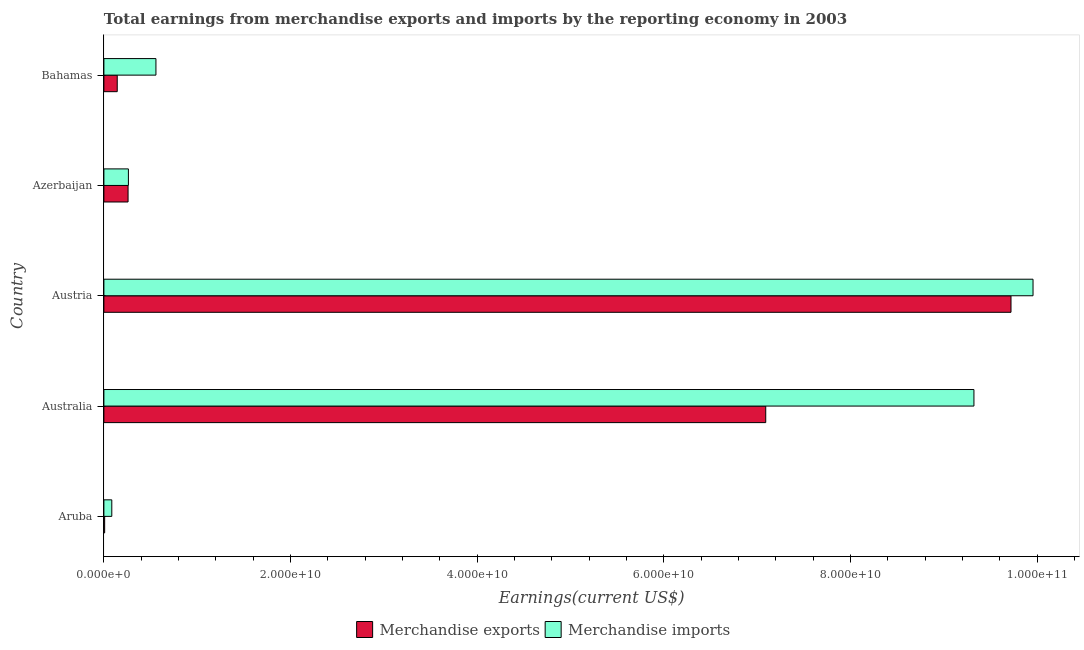How many different coloured bars are there?
Ensure brevity in your answer.  2. Are the number of bars per tick equal to the number of legend labels?
Your answer should be very brief. Yes. Are the number of bars on each tick of the Y-axis equal?
Provide a succinct answer. Yes. How many bars are there on the 4th tick from the bottom?
Offer a terse response. 2. What is the label of the 1st group of bars from the top?
Provide a succinct answer. Bahamas. In how many cases, is the number of bars for a given country not equal to the number of legend labels?
Ensure brevity in your answer.  0. What is the earnings from merchandise exports in Bahamas?
Offer a very short reply. 1.43e+09. Across all countries, what is the maximum earnings from merchandise imports?
Give a very brief answer. 9.95e+1. Across all countries, what is the minimum earnings from merchandise imports?
Provide a succinct answer. 8.47e+08. In which country was the earnings from merchandise imports maximum?
Make the answer very short. Austria. In which country was the earnings from merchandise imports minimum?
Your answer should be very brief. Aruba. What is the total earnings from merchandise exports in the graph?
Your answer should be very brief. 1.72e+11. What is the difference between the earnings from merchandise imports in Aruba and that in Australia?
Offer a very short reply. -9.24e+1. What is the difference between the earnings from merchandise imports in Azerbaijan and the earnings from merchandise exports in Bahamas?
Give a very brief answer. 1.20e+09. What is the average earnings from merchandise imports per country?
Give a very brief answer. 4.04e+1. What is the difference between the earnings from merchandise exports and earnings from merchandise imports in Austria?
Make the answer very short. -2.36e+09. What is the ratio of the earnings from merchandise exports in Aruba to that in Azerbaijan?
Your response must be concise. 0.03. What is the difference between the highest and the second highest earnings from merchandise exports?
Offer a very short reply. 2.63e+1. What is the difference between the highest and the lowest earnings from merchandise exports?
Provide a succinct answer. 9.71e+1. How many bars are there?
Offer a terse response. 10. How many countries are there in the graph?
Provide a succinct answer. 5. Are the values on the major ticks of X-axis written in scientific E-notation?
Provide a short and direct response. Yes. Where does the legend appear in the graph?
Provide a short and direct response. Bottom center. How many legend labels are there?
Provide a short and direct response. 2. How are the legend labels stacked?
Offer a terse response. Horizontal. What is the title of the graph?
Provide a succinct answer. Total earnings from merchandise exports and imports by the reporting economy in 2003. Does "Food" appear as one of the legend labels in the graph?
Your answer should be very brief. No. What is the label or title of the X-axis?
Offer a terse response. Earnings(current US$). What is the label or title of the Y-axis?
Provide a short and direct response. Country. What is the Earnings(current US$) of Merchandise exports in Aruba?
Ensure brevity in your answer.  8.22e+07. What is the Earnings(current US$) in Merchandise imports in Aruba?
Offer a very short reply. 8.47e+08. What is the Earnings(current US$) of Merchandise exports in Australia?
Give a very brief answer. 7.09e+1. What is the Earnings(current US$) of Merchandise imports in Australia?
Your response must be concise. 9.32e+1. What is the Earnings(current US$) of Merchandise exports in Austria?
Provide a succinct answer. 9.72e+1. What is the Earnings(current US$) of Merchandise imports in Austria?
Provide a succinct answer. 9.95e+1. What is the Earnings(current US$) in Merchandise exports in Azerbaijan?
Offer a terse response. 2.59e+09. What is the Earnings(current US$) of Merchandise imports in Azerbaijan?
Provide a short and direct response. 2.63e+09. What is the Earnings(current US$) of Merchandise exports in Bahamas?
Ensure brevity in your answer.  1.43e+09. What is the Earnings(current US$) in Merchandise imports in Bahamas?
Make the answer very short. 5.58e+09. Across all countries, what is the maximum Earnings(current US$) in Merchandise exports?
Your answer should be compact. 9.72e+1. Across all countries, what is the maximum Earnings(current US$) in Merchandise imports?
Provide a succinct answer. 9.95e+1. Across all countries, what is the minimum Earnings(current US$) in Merchandise exports?
Keep it short and to the point. 8.22e+07. Across all countries, what is the minimum Earnings(current US$) in Merchandise imports?
Keep it short and to the point. 8.47e+08. What is the total Earnings(current US$) in Merchandise exports in the graph?
Your answer should be very brief. 1.72e+11. What is the total Earnings(current US$) of Merchandise imports in the graph?
Your response must be concise. 2.02e+11. What is the difference between the Earnings(current US$) of Merchandise exports in Aruba and that in Australia?
Your answer should be very brief. -7.08e+1. What is the difference between the Earnings(current US$) of Merchandise imports in Aruba and that in Australia?
Offer a very short reply. -9.24e+1. What is the difference between the Earnings(current US$) of Merchandise exports in Aruba and that in Austria?
Offer a terse response. -9.71e+1. What is the difference between the Earnings(current US$) in Merchandise imports in Aruba and that in Austria?
Your response must be concise. -9.87e+1. What is the difference between the Earnings(current US$) of Merchandise exports in Aruba and that in Azerbaijan?
Ensure brevity in your answer.  -2.51e+09. What is the difference between the Earnings(current US$) of Merchandise imports in Aruba and that in Azerbaijan?
Provide a succinct answer. -1.78e+09. What is the difference between the Earnings(current US$) of Merchandise exports in Aruba and that in Bahamas?
Your response must be concise. -1.35e+09. What is the difference between the Earnings(current US$) in Merchandise imports in Aruba and that in Bahamas?
Provide a succinct answer. -4.73e+09. What is the difference between the Earnings(current US$) in Merchandise exports in Australia and that in Austria?
Offer a terse response. -2.63e+1. What is the difference between the Earnings(current US$) in Merchandise imports in Australia and that in Austria?
Ensure brevity in your answer.  -6.33e+09. What is the difference between the Earnings(current US$) of Merchandise exports in Australia and that in Azerbaijan?
Keep it short and to the point. 6.83e+1. What is the difference between the Earnings(current US$) in Merchandise imports in Australia and that in Azerbaijan?
Your answer should be compact. 9.06e+1. What is the difference between the Earnings(current US$) in Merchandise exports in Australia and that in Bahamas?
Your answer should be compact. 6.95e+1. What is the difference between the Earnings(current US$) of Merchandise imports in Australia and that in Bahamas?
Keep it short and to the point. 8.76e+1. What is the difference between the Earnings(current US$) in Merchandise exports in Austria and that in Azerbaijan?
Your response must be concise. 9.46e+1. What is the difference between the Earnings(current US$) of Merchandise imports in Austria and that in Azerbaijan?
Make the answer very short. 9.69e+1. What is the difference between the Earnings(current US$) of Merchandise exports in Austria and that in Bahamas?
Your answer should be very brief. 9.58e+1. What is the difference between the Earnings(current US$) in Merchandise imports in Austria and that in Bahamas?
Offer a very short reply. 9.40e+1. What is the difference between the Earnings(current US$) in Merchandise exports in Azerbaijan and that in Bahamas?
Make the answer very short. 1.16e+09. What is the difference between the Earnings(current US$) of Merchandise imports in Azerbaijan and that in Bahamas?
Your response must be concise. -2.95e+09. What is the difference between the Earnings(current US$) of Merchandise exports in Aruba and the Earnings(current US$) of Merchandise imports in Australia?
Your answer should be compact. -9.31e+1. What is the difference between the Earnings(current US$) in Merchandise exports in Aruba and the Earnings(current US$) in Merchandise imports in Austria?
Provide a succinct answer. -9.95e+1. What is the difference between the Earnings(current US$) in Merchandise exports in Aruba and the Earnings(current US$) in Merchandise imports in Azerbaijan?
Provide a succinct answer. -2.54e+09. What is the difference between the Earnings(current US$) in Merchandise exports in Aruba and the Earnings(current US$) in Merchandise imports in Bahamas?
Ensure brevity in your answer.  -5.49e+09. What is the difference between the Earnings(current US$) of Merchandise exports in Australia and the Earnings(current US$) of Merchandise imports in Austria?
Offer a terse response. -2.86e+1. What is the difference between the Earnings(current US$) in Merchandise exports in Australia and the Earnings(current US$) in Merchandise imports in Azerbaijan?
Offer a terse response. 6.83e+1. What is the difference between the Earnings(current US$) of Merchandise exports in Australia and the Earnings(current US$) of Merchandise imports in Bahamas?
Your answer should be compact. 6.53e+1. What is the difference between the Earnings(current US$) of Merchandise exports in Austria and the Earnings(current US$) of Merchandise imports in Azerbaijan?
Provide a succinct answer. 9.46e+1. What is the difference between the Earnings(current US$) of Merchandise exports in Austria and the Earnings(current US$) of Merchandise imports in Bahamas?
Provide a succinct answer. 9.16e+1. What is the difference between the Earnings(current US$) of Merchandise exports in Azerbaijan and the Earnings(current US$) of Merchandise imports in Bahamas?
Keep it short and to the point. -2.99e+09. What is the average Earnings(current US$) in Merchandise exports per country?
Your answer should be very brief. 3.44e+1. What is the average Earnings(current US$) in Merchandise imports per country?
Offer a terse response. 4.04e+1. What is the difference between the Earnings(current US$) of Merchandise exports and Earnings(current US$) of Merchandise imports in Aruba?
Your answer should be very brief. -7.64e+08. What is the difference between the Earnings(current US$) in Merchandise exports and Earnings(current US$) in Merchandise imports in Australia?
Make the answer very short. -2.23e+1. What is the difference between the Earnings(current US$) of Merchandise exports and Earnings(current US$) of Merchandise imports in Austria?
Ensure brevity in your answer.  -2.36e+09. What is the difference between the Earnings(current US$) of Merchandise exports and Earnings(current US$) of Merchandise imports in Azerbaijan?
Make the answer very short. -3.56e+07. What is the difference between the Earnings(current US$) of Merchandise exports and Earnings(current US$) of Merchandise imports in Bahamas?
Ensure brevity in your answer.  -4.15e+09. What is the ratio of the Earnings(current US$) in Merchandise exports in Aruba to that in Australia?
Your answer should be compact. 0. What is the ratio of the Earnings(current US$) of Merchandise imports in Aruba to that in Australia?
Provide a succinct answer. 0.01. What is the ratio of the Earnings(current US$) in Merchandise exports in Aruba to that in Austria?
Give a very brief answer. 0. What is the ratio of the Earnings(current US$) of Merchandise imports in Aruba to that in Austria?
Provide a succinct answer. 0.01. What is the ratio of the Earnings(current US$) of Merchandise exports in Aruba to that in Azerbaijan?
Offer a very short reply. 0.03. What is the ratio of the Earnings(current US$) of Merchandise imports in Aruba to that in Azerbaijan?
Ensure brevity in your answer.  0.32. What is the ratio of the Earnings(current US$) in Merchandise exports in Aruba to that in Bahamas?
Provide a succinct answer. 0.06. What is the ratio of the Earnings(current US$) in Merchandise imports in Aruba to that in Bahamas?
Your answer should be very brief. 0.15. What is the ratio of the Earnings(current US$) in Merchandise exports in Australia to that in Austria?
Offer a very short reply. 0.73. What is the ratio of the Earnings(current US$) of Merchandise imports in Australia to that in Austria?
Make the answer very short. 0.94. What is the ratio of the Earnings(current US$) of Merchandise exports in Australia to that in Azerbaijan?
Provide a succinct answer. 27.38. What is the ratio of the Earnings(current US$) in Merchandise imports in Australia to that in Azerbaijan?
Ensure brevity in your answer.  35.5. What is the ratio of the Earnings(current US$) in Merchandise exports in Australia to that in Bahamas?
Offer a terse response. 49.64. What is the ratio of the Earnings(current US$) of Merchandise imports in Australia to that in Bahamas?
Keep it short and to the point. 16.72. What is the ratio of the Earnings(current US$) in Merchandise exports in Austria to that in Azerbaijan?
Keep it short and to the point. 37.52. What is the ratio of the Earnings(current US$) of Merchandise imports in Austria to that in Azerbaijan?
Your answer should be very brief. 37.91. What is the ratio of the Earnings(current US$) in Merchandise exports in Austria to that in Bahamas?
Your answer should be compact. 68.03. What is the ratio of the Earnings(current US$) of Merchandise imports in Austria to that in Bahamas?
Keep it short and to the point. 17.85. What is the ratio of the Earnings(current US$) of Merchandise exports in Azerbaijan to that in Bahamas?
Ensure brevity in your answer.  1.81. What is the ratio of the Earnings(current US$) in Merchandise imports in Azerbaijan to that in Bahamas?
Make the answer very short. 0.47. What is the difference between the highest and the second highest Earnings(current US$) of Merchandise exports?
Your answer should be very brief. 2.63e+1. What is the difference between the highest and the second highest Earnings(current US$) of Merchandise imports?
Keep it short and to the point. 6.33e+09. What is the difference between the highest and the lowest Earnings(current US$) in Merchandise exports?
Offer a very short reply. 9.71e+1. What is the difference between the highest and the lowest Earnings(current US$) in Merchandise imports?
Offer a terse response. 9.87e+1. 